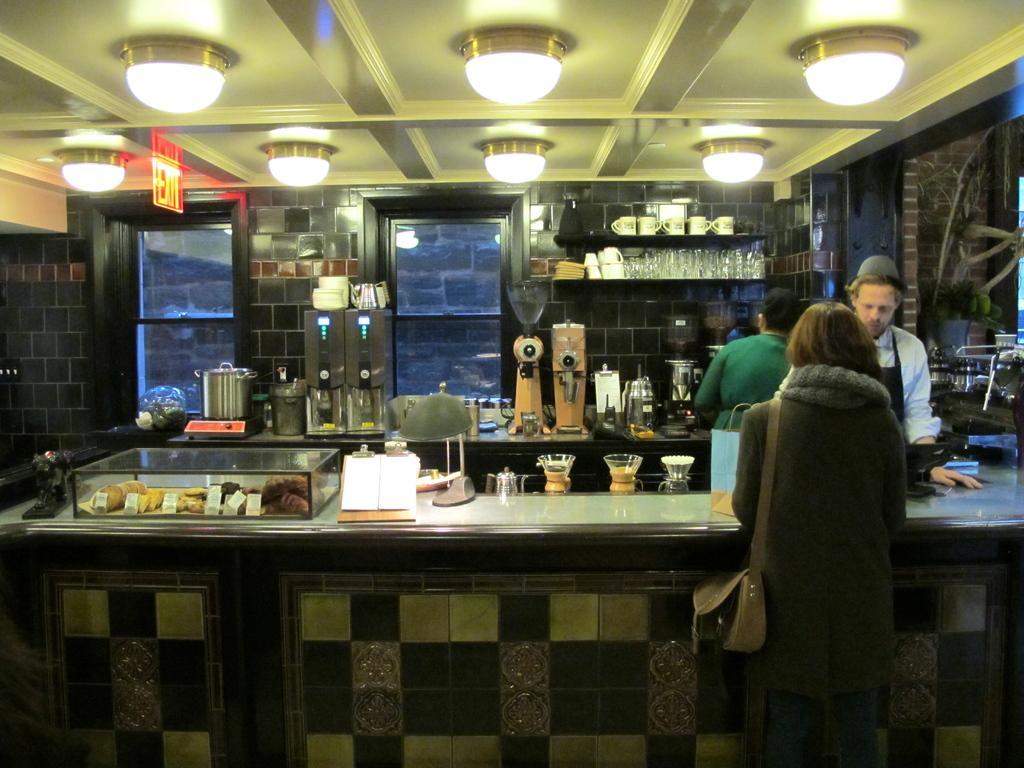Describe this image in one or two sentences. One lady wearing a bag standing near to the table. And on the table some items are kept. And also one person wearing apron is standing there. In the background there are some glasses in the cupboard. On the ceiling there are lights. So many items are kept on the table. 